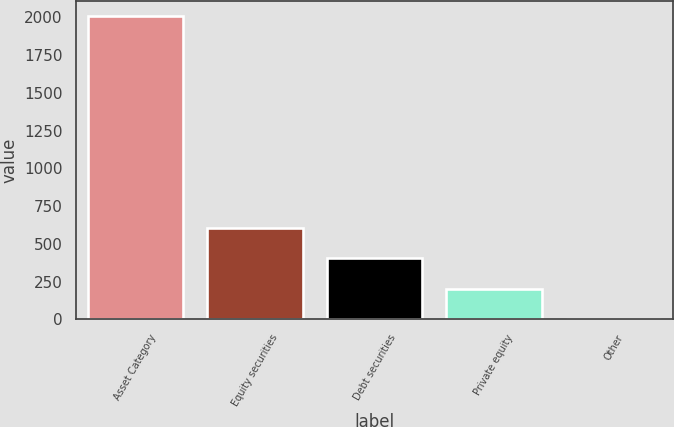Convert chart. <chart><loc_0><loc_0><loc_500><loc_500><bar_chart><fcel>Asset Category<fcel>Equity securities<fcel>Debt securities<fcel>Private equity<fcel>Other<nl><fcel>2010<fcel>604.4<fcel>403.6<fcel>202.8<fcel>2<nl></chart> 